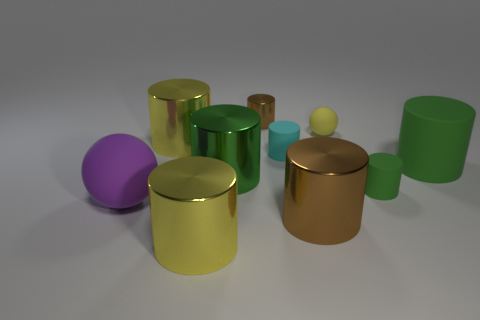Subtract all green blocks. How many green cylinders are left? 3 Subtract all cyan cylinders. How many cylinders are left? 7 Subtract all large rubber cylinders. How many cylinders are left? 7 Subtract all blue cylinders. Subtract all purple blocks. How many cylinders are left? 8 Subtract all spheres. How many objects are left? 8 Add 8 big purple balls. How many big purple balls are left? 9 Add 1 small cyan rubber cylinders. How many small cyan rubber cylinders exist? 2 Subtract 0 gray spheres. How many objects are left? 10 Subtract all large purple matte spheres. Subtract all matte spheres. How many objects are left? 7 